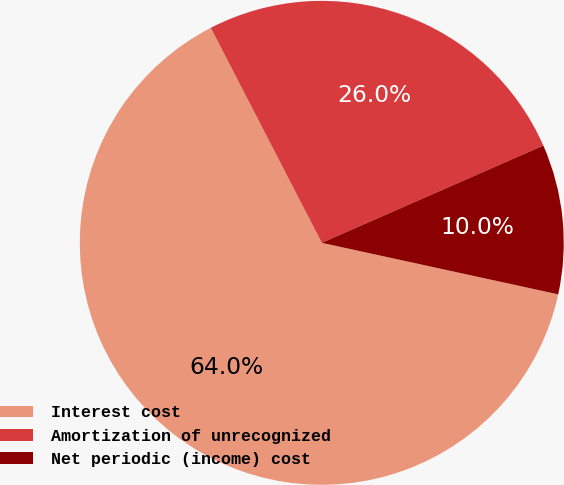Convert chart to OTSL. <chart><loc_0><loc_0><loc_500><loc_500><pie_chart><fcel>Interest cost<fcel>Amortization of unrecognized<fcel>Net periodic (income) cost<nl><fcel>64.0%<fcel>26.0%<fcel>10.0%<nl></chart> 